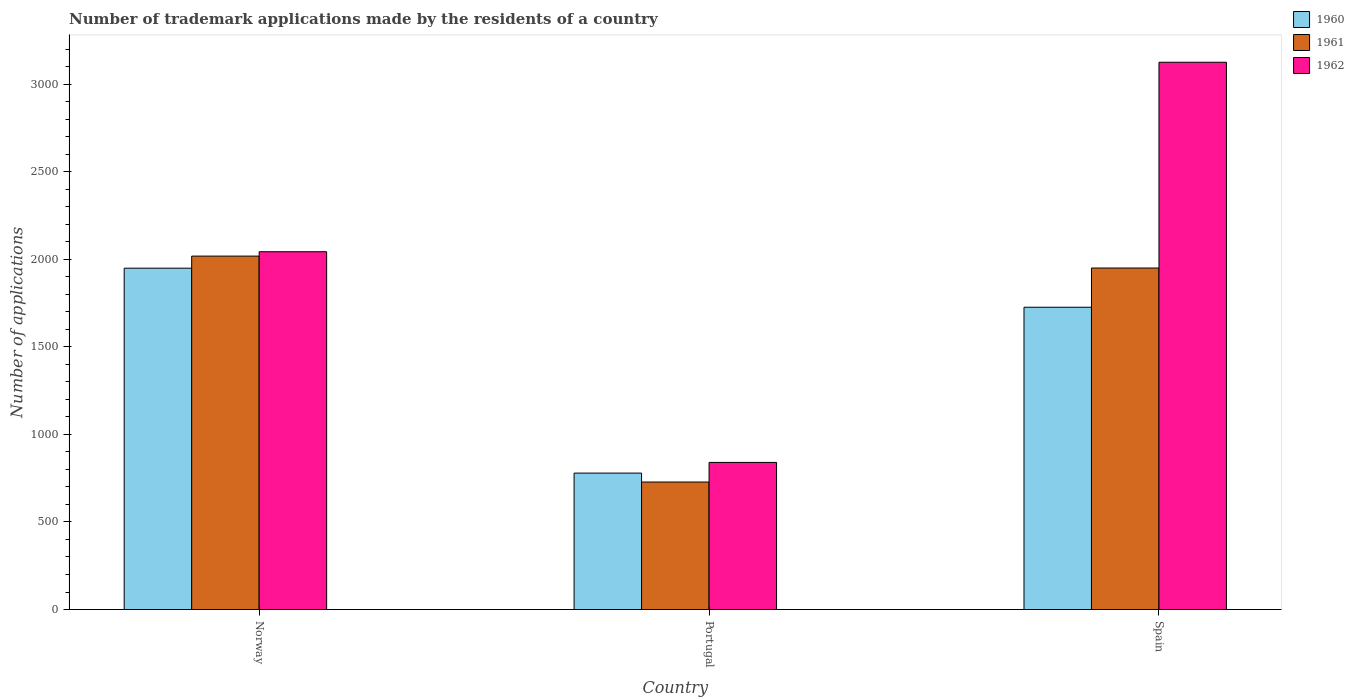How many different coloured bars are there?
Ensure brevity in your answer.  3. How many groups of bars are there?
Provide a short and direct response. 3. Are the number of bars on each tick of the X-axis equal?
Offer a very short reply. Yes. What is the label of the 1st group of bars from the left?
Give a very brief answer. Norway. In how many cases, is the number of bars for a given country not equal to the number of legend labels?
Offer a terse response. 0. What is the number of trademark applications made by the residents in 1960 in Portugal?
Keep it short and to the point. 779. Across all countries, what is the maximum number of trademark applications made by the residents in 1960?
Your answer should be compact. 1949. Across all countries, what is the minimum number of trademark applications made by the residents in 1960?
Your answer should be compact. 779. In which country was the number of trademark applications made by the residents in 1960 maximum?
Make the answer very short. Norway. What is the total number of trademark applications made by the residents in 1961 in the graph?
Your response must be concise. 4696. What is the difference between the number of trademark applications made by the residents in 1960 in Portugal and that in Spain?
Give a very brief answer. -947. What is the difference between the number of trademark applications made by the residents in 1961 in Spain and the number of trademark applications made by the residents in 1962 in Norway?
Give a very brief answer. -93. What is the average number of trademark applications made by the residents in 1962 per country?
Ensure brevity in your answer.  2002.67. What is the difference between the number of trademark applications made by the residents of/in 1960 and number of trademark applications made by the residents of/in 1962 in Norway?
Give a very brief answer. -94. What is the ratio of the number of trademark applications made by the residents in 1962 in Norway to that in Spain?
Ensure brevity in your answer.  0.65. Is the number of trademark applications made by the residents in 1962 in Norway less than that in Portugal?
Your answer should be very brief. No. What is the difference between the highest and the second highest number of trademark applications made by the residents in 1960?
Your answer should be very brief. -1170. What is the difference between the highest and the lowest number of trademark applications made by the residents in 1960?
Give a very brief answer. 1170. What does the 1st bar from the left in Norway represents?
Offer a terse response. 1960. What does the 3rd bar from the right in Norway represents?
Give a very brief answer. 1960. Is it the case that in every country, the sum of the number of trademark applications made by the residents in 1962 and number of trademark applications made by the residents in 1960 is greater than the number of trademark applications made by the residents in 1961?
Keep it short and to the point. Yes. How many bars are there?
Provide a short and direct response. 9. Are all the bars in the graph horizontal?
Provide a succinct answer. No. What is the difference between two consecutive major ticks on the Y-axis?
Your answer should be compact. 500. Are the values on the major ticks of Y-axis written in scientific E-notation?
Your answer should be very brief. No. Does the graph contain grids?
Offer a terse response. No. Where does the legend appear in the graph?
Offer a very short reply. Top right. What is the title of the graph?
Make the answer very short. Number of trademark applications made by the residents of a country. What is the label or title of the X-axis?
Provide a succinct answer. Country. What is the label or title of the Y-axis?
Offer a very short reply. Number of applications. What is the Number of applications in 1960 in Norway?
Your answer should be compact. 1949. What is the Number of applications in 1961 in Norway?
Give a very brief answer. 2018. What is the Number of applications in 1962 in Norway?
Give a very brief answer. 2043. What is the Number of applications in 1960 in Portugal?
Make the answer very short. 779. What is the Number of applications of 1961 in Portugal?
Your answer should be compact. 728. What is the Number of applications in 1962 in Portugal?
Your answer should be very brief. 840. What is the Number of applications of 1960 in Spain?
Offer a terse response. 1726. What is the Number of applications in 1961 in Spain?
Your answer should be compact. 1950. What is the Number of applications in 1962 in Spain?
Provide a short and direct response. 3125. Across all countries, what is the maximum Number of applications in 1960?
Provide a short and direct response. 1949. Across all countries, what is the maximum Number of applications of 1961?
Give a very brief answer. 2018. Across all countries, what is the maximum Number of applications in 1962?
Keep it short and to the point. 3125. Across all countries, what is the minimum Number of applications of 1960?
Make the answer very short. 779. Across all countries, what is the minimum Number of applications of 1961?
Ensure brevity in your answer.  728. Across all countries, what is the minimum Number of applications of 1962?
Provide a short and direct response. 840. What is the total Number of applications of 1960 in the graph?
Give a very brief answer. 4454. What is the total Number of applications of 1961 in the graph?
Your answer should be very brief. 4696. What is the total Number of applications of 1962 in the graph?
Keep it short and to the point. 6008. What is the difference between the Number of applications in 1960 in Norway and that in Portugal?
Offer a terse response. 1170. What is the difference between the Number of applications of 1961 in Norway and that in Portugal?
Offer a very short reply. 1290. What is the difference between the Number of applications in 1962 in Norway and that in Portugal?
Give a very brief answer. 1203. What is the difference between the Number of applications in 1960 in Norway and that in Spain?
Your answer should be very brief. 223. What is the difference between the Number of applications of 1962 in Norway and that in Spain?
Give a very brief answer. -1082. What is the difference between the Number of applications of 1960 in Portugal and that in Spain?
Offer a very short reply. -947. What is the difference between the Number of applications in 1961 in Portugal and that in Spain?
Your response must be concise. -1222. What is the difference between the Number of applications of 1962 in Portugal and that in Spain?
Provide a succinct answer. -2285. What is the difference between the Number of applications of 1960 in Norway and the Number of applications of 1961 in Portugal?
Give a very brief answer. 1221. What is the difference between the Number of applications of 1960 in Norway and the Number of applications of 1962 in Portugal?
Give a very brief answer. 1109. What is the difference between the Number of applications of 1961 in Norway and the Number of applications of 1962 in Portugal?
Ensure brevity in your answer.  1178. What is the difference between the Number of applications in 1960 in Norway and the Number of applications in 1961 in Spain?
Keep it short and to the point. -1. What is the difference between the Number of applications of 1960 in Norway and the Number of applications of 1962 in Spain?
Offer a terse response. -1176. What is the difference between the Number of applications in 1961 in Norway and the Number of applications in 1962 in Spain?
Your response must be concise. -1107. What is the difference between the Number of applications in 1960 in Portugal and the Number of applications in 1961 in Spain?
Provide a succinct answer. -1171. What is the difference between the Number of applications of 1960 in Portugal and the Number of applications of 1962 in Spain?
Provide a short and direct response. -2346. What is the difference between the Number of applications of 1961 in Portugal and the Number of applications of 1962 in Spain?
Provide a succinct answer. -2397. What is the average Number of applications of 1960 per country?
Offer a very short reply. 1484.67. What is the average Number of applications of 1961 per country?
Ensure brevity in your answer.  1565.33. What is the average Number of applications of 1962 per country?
Your response must be concise. 2002.67. What is the difference between the Number of applications of 1960 and Number of applications of 1961 in Norway?
Offer a terse response. -69. What is the difference between the Number of applications in 1960 and Number of applications in 1962 in Norway?
Give a very brief answer. -94. What is the difference between the Number of applications of 1960 and Number of applications of 1961 in Portugal?
Give a very brief answer. 51. What is the difference between the Number of applications in 1960 and Number of applications in 1962 in Portugal?
Provide a short and direct response. -61. What is the difference between the Number of applications of 1961 and Number of applications of 1962 in Portugal?
Your answer should be compact. -112. What is the difference between the Number of applications of 1960 and Number of applications of 1961 in Spain?
Your answer should be very brief. -224. What is the difference between the Number of applications in 1960 and Number of applications in 1962 in Spain?
Provide a succinct answer. -1399. What is the difference between the Number of applications in 1961 and Number of applications in 1962 in Spain?
Provide a succinct answer. -1175. What is the ratio of the Number of applications of 1960 in Norway to that in Portugal?
Keep it short and to the point. 2.5. What is the ratio of the Number of applications in 1961 in Norway to that in Portugal?
Offer a very short reply. 2.77. What is the ratio of the Number of applications of 1962 in Norway to that in Portugal?
Your answer should be compact. 2.43. What is the ratio of the Number of applications in 1960 in Norway to that in Spain?
Make the answer very short. 1.13. What is the ratio of the Number of applications of 1961 in Norway to that in Spain?
Make the answer very short. 1.03. What is the ratio of the Number of applications in 1962 in Norway to that in Spain?
Give a very brief answer. 0.65. What is the ratio of the Number of applications in 1960 in Portugal to that in Spain?
Make the answer very short. 0.45. What is the ratio of the Number of applications in 1961 in Portugal to that in Spain?
Provide a succinct answer. 0.37. What is the ratio of the Number of applications in 1962 in Portugal to that in Spain?
Offer a very short reply. 0.27. What is the difference between the highest and the second highest Number of applications of 1960?
Your answer should be very brief. 223. What is the difference between the highest and the second highest Number of applications in 1961?
Provide a succinct answer. 68. What is the difference between the highest and the second highest Number of applications in 1962?
Make the answer very short. 1082. What is the difference between the highest and the lowest Number of applications in 1960?
Make the answer very short. 1170. What is the difference between the highest and the lowest Number of applications of 1961?
Make the answer very short. 1290. What is the difference between the highest and the lowest Number of applications of 1962?
Offer a very short reply. 2285. 